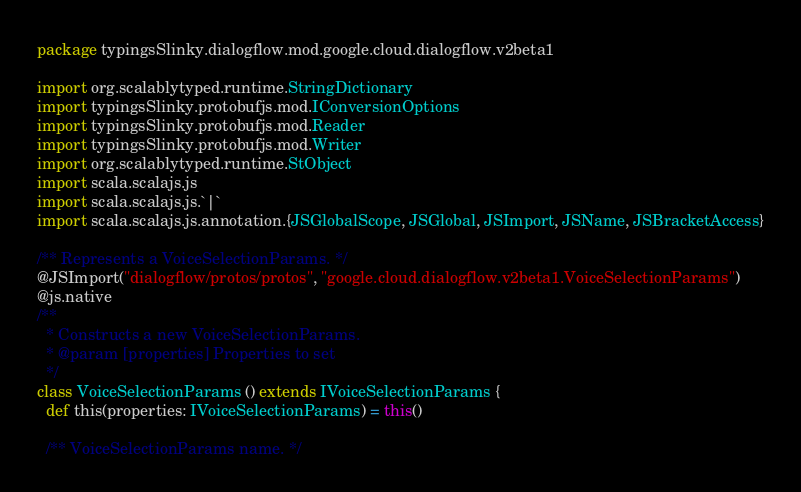<code> <loc_0><loc_0><loc_500><loc_500><_Scala_>package typingsSlinky.dialogflow.mod.google.cloud.dialogflow.v2beta1

import org.scalablytyped.runtime.StringDictionary
import typingsSlinky.protobufjs.mod.IConversionOptions
import typingsSlinky.protobufjs.mod.Reader
import typingsSlinky.protobufjs.mod.Writer
import org.scalablytyped.runtime.StObject
import scala.scalajs.js
import scala.scalajs.js.`|`
import scala.scalajs.js.annotation.{JSGlobalScope, JSGlobal, JSImport, JSName, JSBracketAccess}

/** Represents a VoiceSelectionParams. */
@JSImport("dialogflow/protos/protos", "google.cloud.dialogflow.v2beta1.VoiceSelectionParams")
@js.native
/**
  * Constructs a new VoiceSelectionParams.
  * @param [properties] Properties to set
  */
class VoiceSelectionParams () extends IVoiceSelectionParams {
  def this(properties: IVoiceSelectionParams) = this()
  
  /** VoiceSelectionParams name. */</code> 